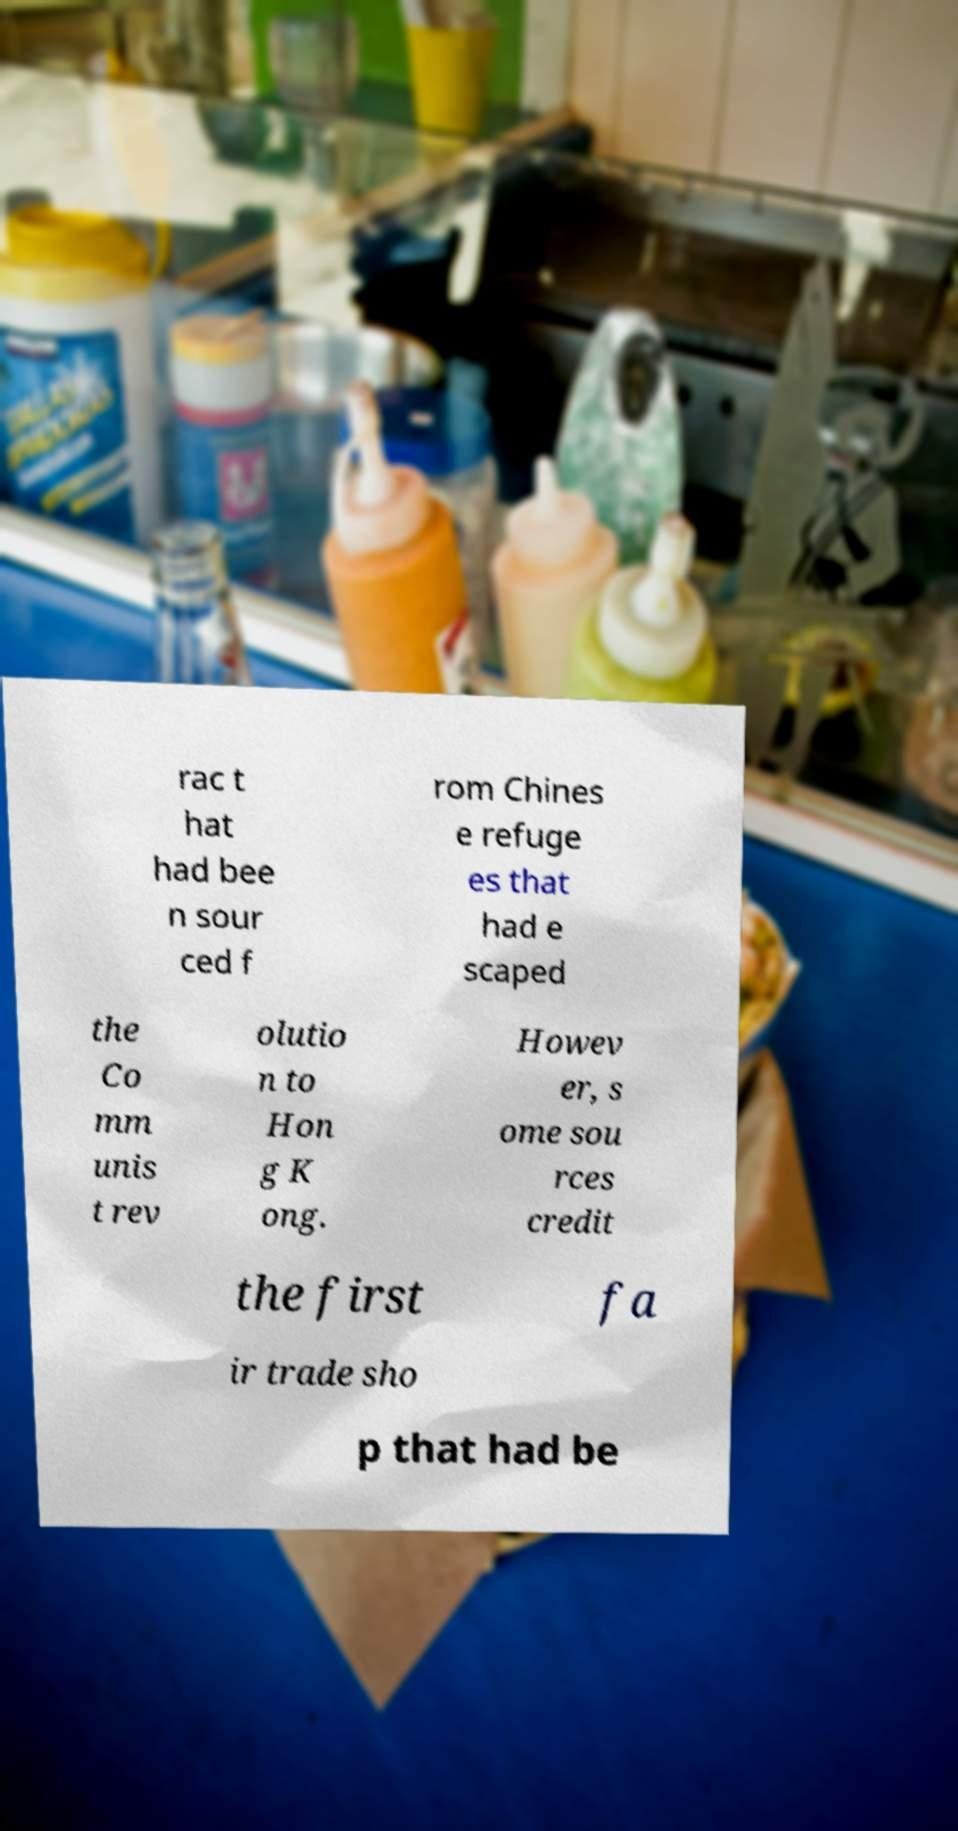Can you accurately transcribe the text from the provided image for me? rac t hat had bee n sour ced f rom Chines e refuge es that had e scaped the Co mm unis t rev olutio n to Hon g K ong. Howev er, s ome sou rces credit the first fa ir trade sho p that had be 